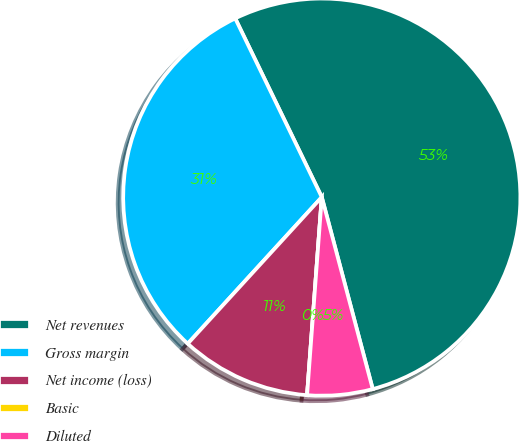Convert chart to OTSL. <chart><loc_0><loc_0><loc_500><loc_500><pie_chart><fcel>Net revenues<fcel>Gross margin<fcel>Net income (loss)<fcel>Basic<fcel>Diluted<nl><fcel>53.05%<fcel>31.03%<fcel>10.61%<fcel>0.0%<fcel>5.31%<nl></chart> 